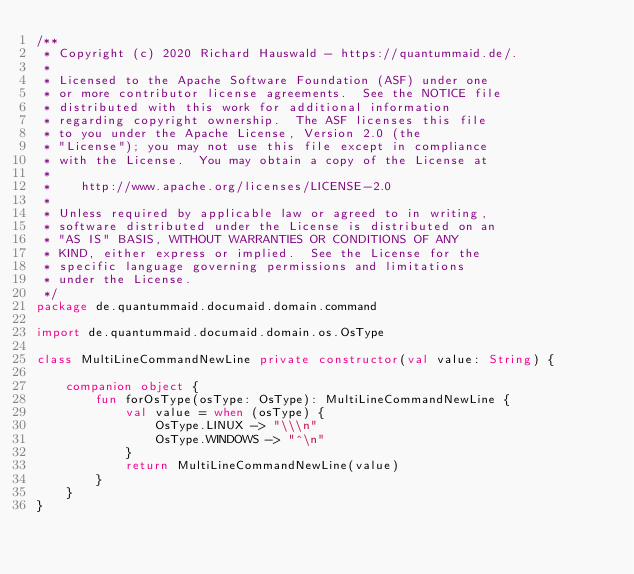<code> <loc_0><loc_0><loc_500><loc_500><_Kotlin_>/**
 * Copyright (c) 2020 Richard Hauswald - https://quantummaid.de/.
 *
 * Licensed to the Apache Software Foundation (ASF) under one
 * or more contributor license agreements.  See the NOTICE file
 * distributed with this work for additional information
 * regarding copyright ownership.  The ASF licenses this file
 * to you under the Apache License, Version 2.0 (the
 * "License"); you may not use this file except in compliance
 * with the License.  You may obtain a copy of the License at
 *
 *    http://www.apache.org/licenses/LICENSE-2.0
 *
 * Unless required by applicable law or agreed to in writing,
 * software distributed under the License is distributed on an
 * "AS IS" BASIS, WITHOUT WARRANTIES OR CONDITIONS OF ANY
 * KIND, either express or implied.  See the License for the
 * specific language governing permissions and limitations
 * under the License.
 */
package de.quantummaid.documaid.domain.command

import de.quantummaid.documaid.domain.os.OsType

class MultiLineCommandNewLine private constructor(val value: String) {

    companion object {
        fun forOsType(osType: OsType): MultiLineCommandNewLine {
            val value = when (osType) {
                OsType.LINUX -> "\\\n"
                OsType.WINDOWS -> "^\n"
            }
            return MultiLineCommandNewLine(value)
        }
    }
}
</code> 